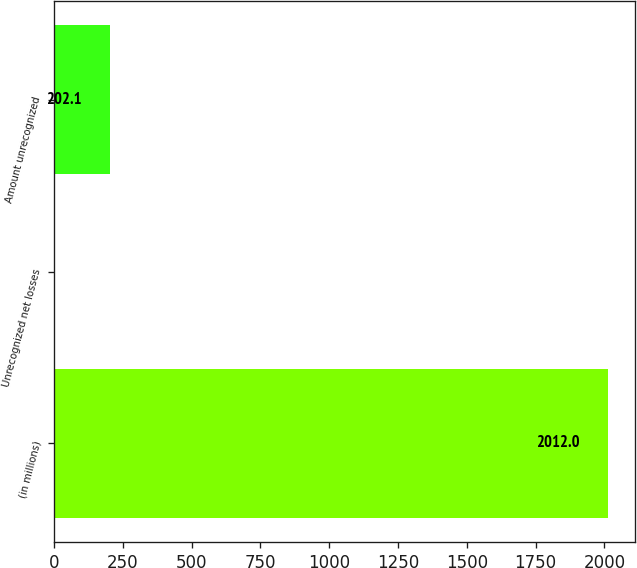Convert chart to OTSL. <chart><loc_0><loc_0><loc_500><loc_500><bar_chart><fcel>(in millions)<fcel>Unrecognized net losses<fcel>Amount unrecognized<nl><fcel>2012<fcel>1<fcel>202.1<nl></chart> 